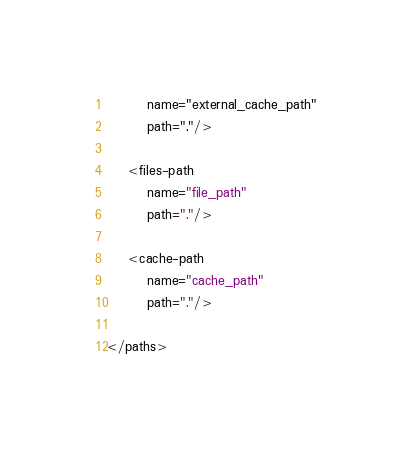<code> <loc_0><loc_0><loc_500><loc_500><_XML_>        name="external_cache_path"
        path="."/>

    <files-path
        name="file_path"
        path="."/>

    <cache-path
        name="cache_path"
        path="."/>

</paths></code> 